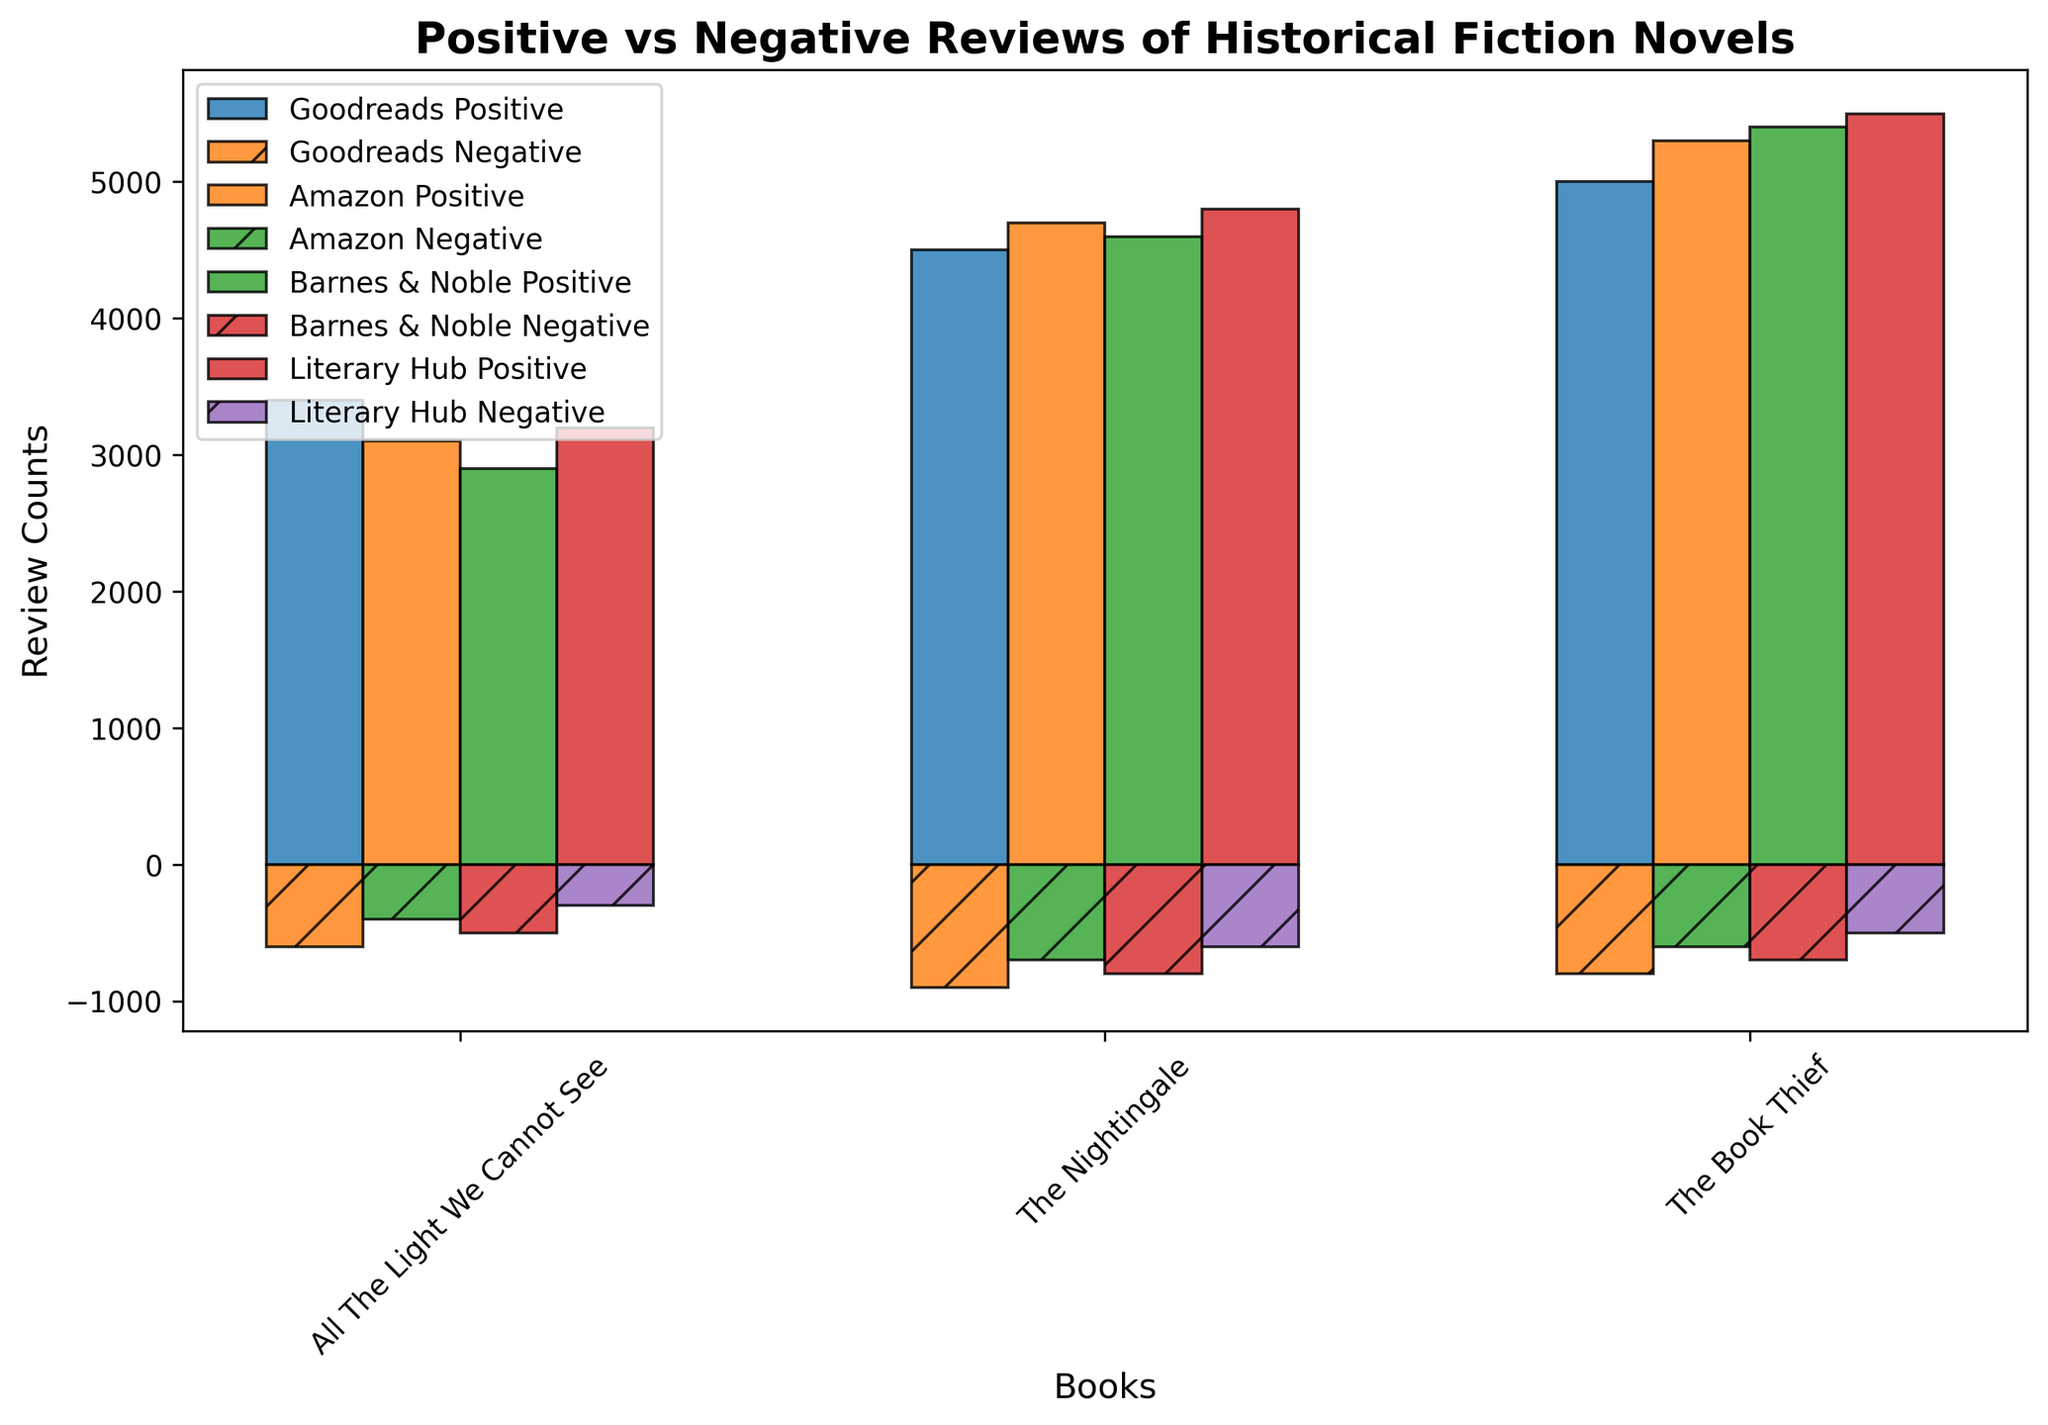What book received the highest number of positive reviews on Amazon? Look at the bar heights for positive reviews on Amazon; "The Book Thief" has the highest bar.
Answer: The Book Thief Which platform gave the most negative reviews for "The Nightingale"? Compare the negative review bars for "The Nightingale" across all platforms; Barnes & Noble has the highest bar.
Answer: Barnes & Noble What's the total number of reviews (positive and negative) for "All The Light We Cannot See" on Goodreads? Add the positive and the negative bars values: 3400 (positive) + 600 (negative) = 4000.
Answer: 4000 Between "The Book Thief" and "The Nightingale," which book has a higher overall positive sentiment on Literary Hub? Compare the positive review bars for both books on Literary Hub; "The Book Thief" has a higher bar with 5500 compared to 4800 for "The Nightingale".
Answer: The Book Thief On which platform does "All The Light We Cannot See" have the highest positive sentiment? Compare all positive review bars for "All The Light We Cannot See" across all platforms; Goodreads has the highest bar with 3400.
Answer: Goodreads Of the three platforms, which one gives the most consistent number of positive reviews across all three books? Check the heights of the positive bars for each platform; Amazon's bars are closest in height to each other.
Answer: Amazon What's the difference between positive and negative reviews of "The Book Thief" on Barnes & Noble? Subtract the negative bar value from the positive bar value: 5400 (positive) - 700 (negative) = 4700.
Answer: 4700 Which book has the lowest number of negative reviews on Literary Hub? Compare the negative review bars on Literary Hub; "All The Light We Cannot See" has the lowest bar with 300.
Answer: All The Light We Cannot See How does the positive sentiment for "The Nightingale" compare between Goodreads and Amazon? Compare the positive review bars for "The Nightingale" on both platforms; Amazon (4700) has a slightly higher bar than Goodreads (4500).
Answer: Amazon What is the visual pattern for negative reviews across all platforms for "The Book Thief"? All platforms show a consistent decrease in review counts in the order: Goodreads, Amazon, Barnes & Noble, Literary Hub.
Answer: Consistent decrease 